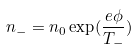Convert formula to latex. <formula><loc_0><loc_0><loc_500><loc_500>n _ { - } = n _ { 0 } \exp ( \frac { e \phi } { T _ { - } } )</formula> 